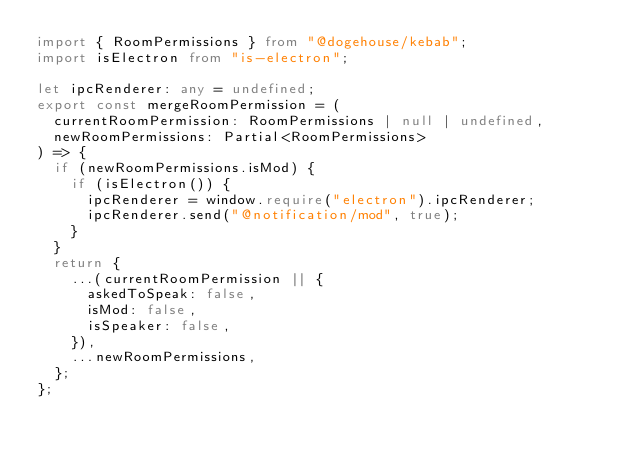<code> <loc_0><loc_0><loc_500><loc_500><_TypeScript_>import { RoomPermissions } from "@dogehouse/kebab";
import isElectron from "is-electron";

let ipcRenderer: any = undefined;
export const mergeRoomPermission = (
  currentRoomPermission: RoomPermissions | null | undefined,
  newRoomPermissions: Partial<RoomPermissions>
) => {
  if (newRoomPermissions.isMod) {
    if (isElectron()) {
      ipcRenderer = window.require("electron").ipcRenderer;
      ipcRenderer.send("@notification/mod", true);
    }
  }
  return {
    ...(currentRoomPermission || {
      askedToSpeak: false,
      isMod: false,
      isSpeaker: false,
    }),
    ...newRoomPermissions,
  };
};
</code> 